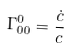<formula> <loc_0><loc_0><loc_500><loc_500>\Gamma ^ { 0 } _ { 0 0 } = \frac { \dot { c } } { c }</formula> 